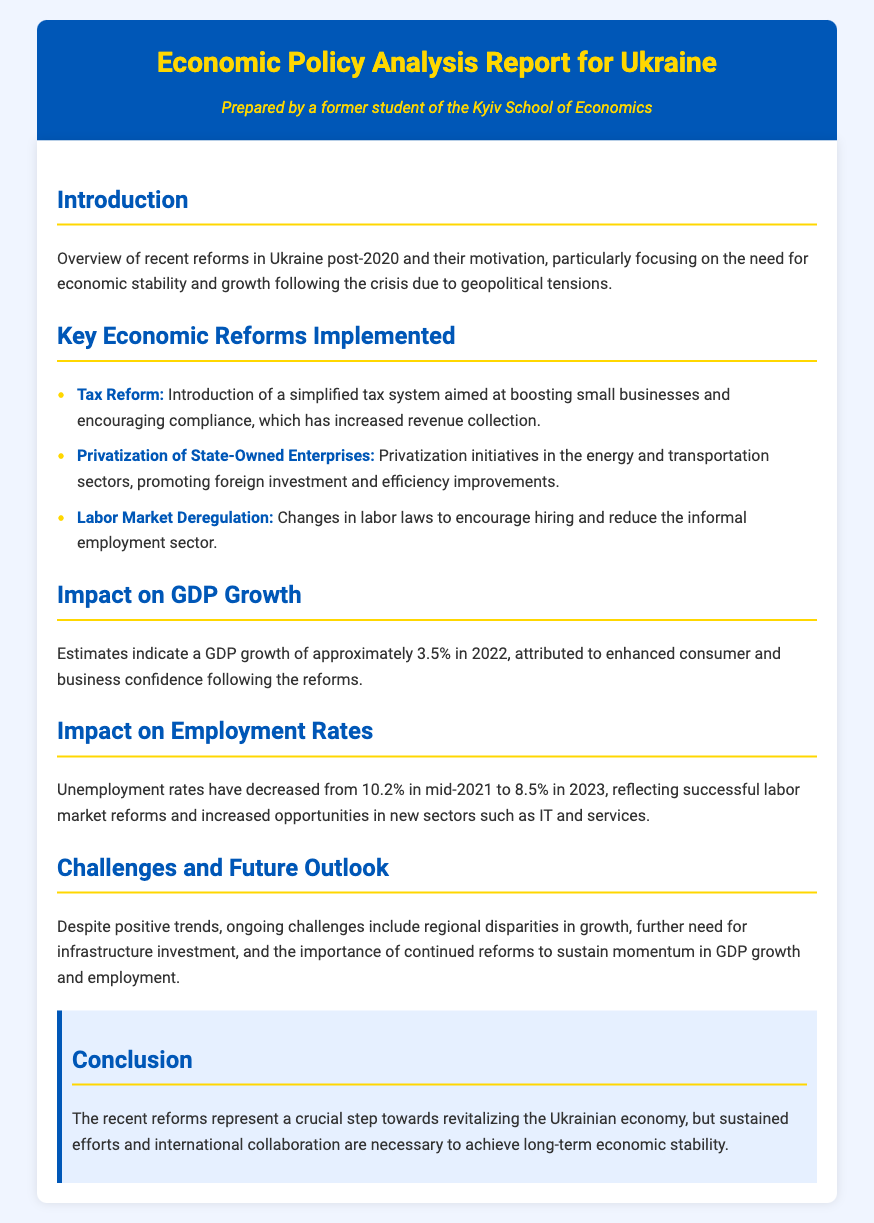What is the GDP growth rate in 2022? The estimated GDP growth is mentioned in the section titled "Impact on GDP Growth," indicating a growth of approximately 3.5% in 2022.
Answer: 3.5% What was the unemployment rate in mid-2021? The document states that the unemployment rate in mid-2021 was 10.2%, as noted in the section "Impact on Employment Rates."
Answer: 10.2% What are the three key reforms implemented? The key reforms listed are Tax Reform, Privatization of State-Owned Enterprises, and Labor Market Deregulation under the section "Key Economic Reforms Implemented."
Answer: Tax Reform, Privatization of State-Owned Enterprises, Labor Market Deregulation What is the unemployment rate in 2023? The document highlights that the unemployment rate decreased to 8.5% in 2023, mentioned in "Impact on Employment Rates."
Answer: 8.5% What is one ongoing challenge mentioned? The "Challenges and Future Outlook" section references ongoing challenges such as regional disparities in growth.
Answer: Regional disparities How has consumer confidence changed post-reforms? The section "Impact on GDP Growth" implies that consumer confidence has enhanced following the reforms, indicating a positive change.
Answer: Enhanced What is the significance of international collaboration according to the conclusion? The conclusion underscores the necessity of international collaboration for achieving long-term economic stability, indicating its importance.
Answer: Necessary What year are the reforms primarily focused on? The introduction refers to recent reforms implemented post-2020, which is the key time frame considered.
Answer: Post-2020 